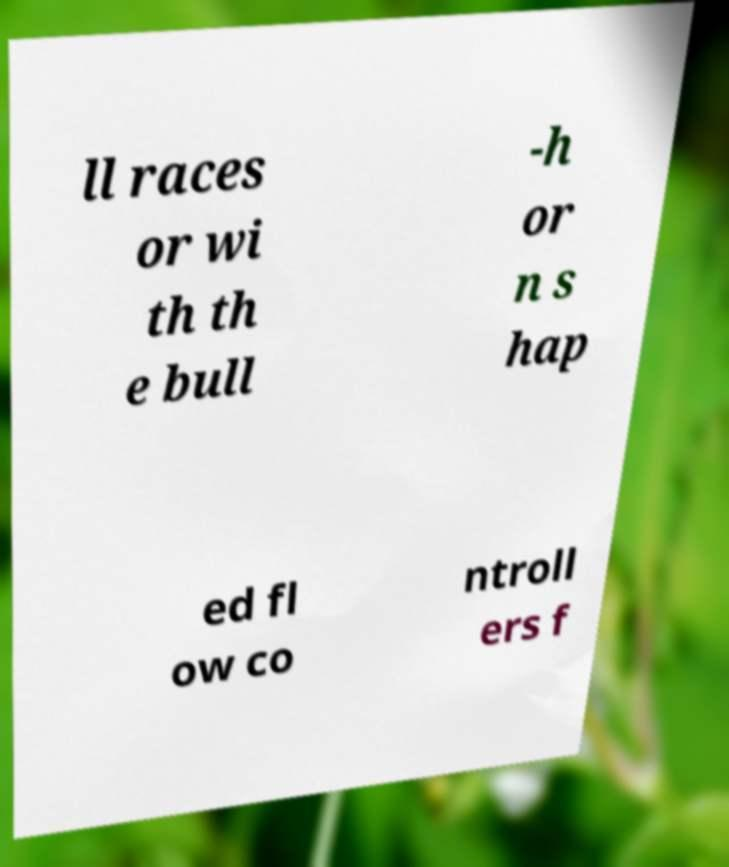For documentation purposes, I need the text within this image transcribed. Could you provide that? ll races or wi th th e bull -h or n s hap ed fl ow co ntroll ers f 